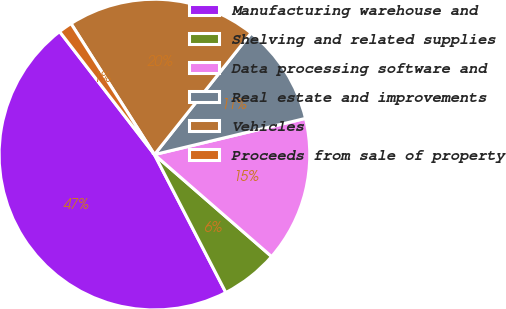Convert chart to OTSL. <chart><loc_0><loc_0><loc_500><loc_500><pie_chart><fcel>Manufacturing warehouse and<fcel>Shelving and related supplies<fcel>Data processing software and<fcel>Real estate and improvements<fcel>Vehicles<fcel>Proceeds from sale of property<nl><fcel>47.15%<fcel>6.0%<fcel>15.14%<fcel>10.57%<fcel>19.71%<fcel>1.43%<nl></chart> 